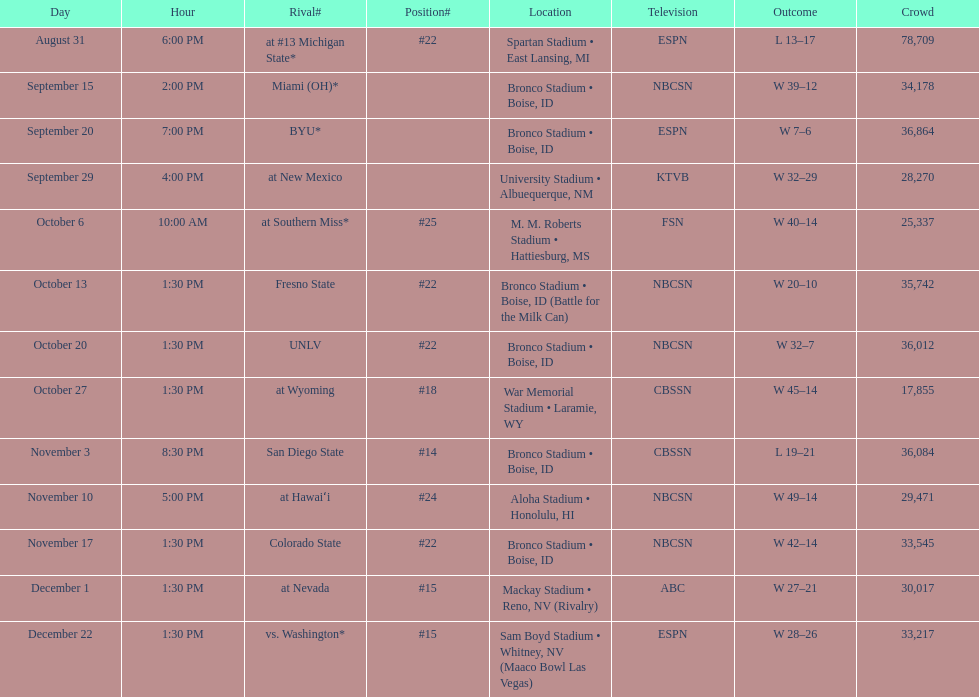What rank was boise state after november 10th? #22. 